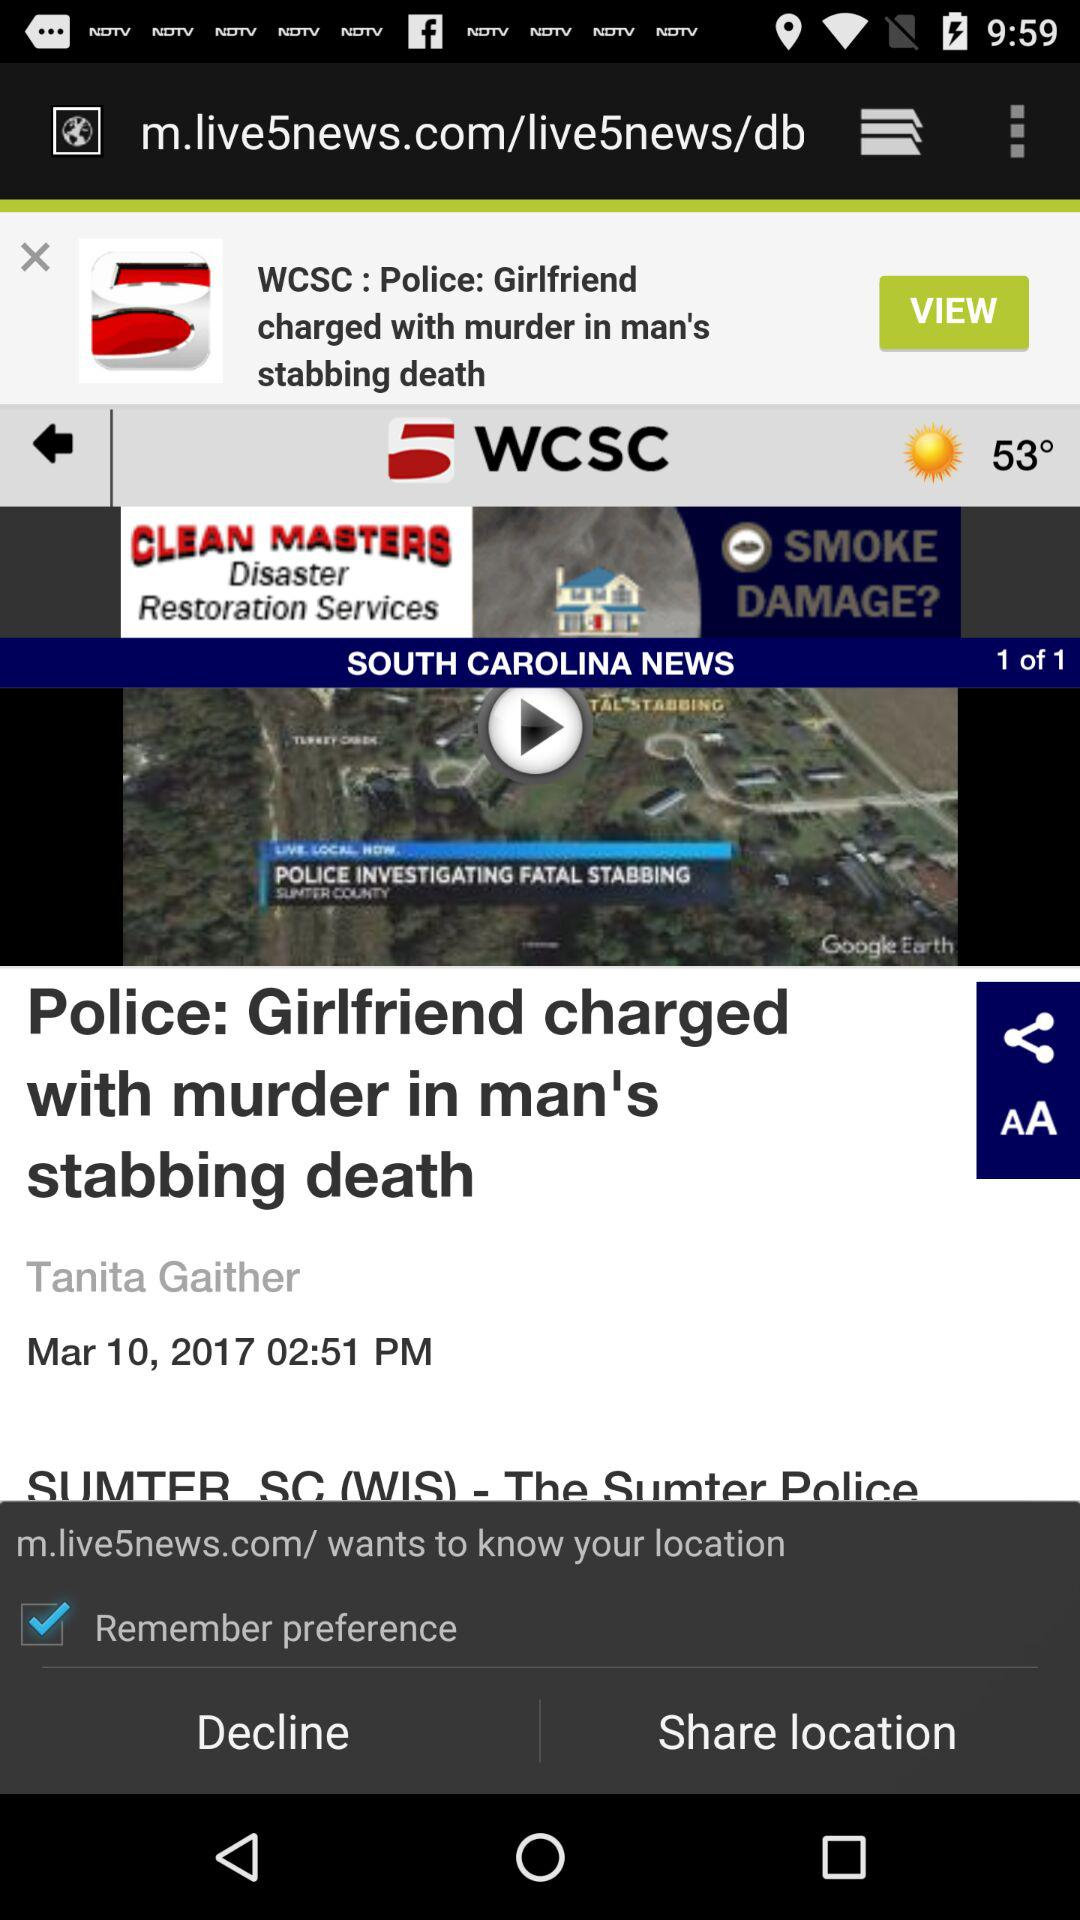What is the posted time of the video titled "Police: Girlfriend charged with murder in man's stabbing death"? The posted time of the video is 2:51 p.m. 